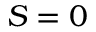<formula> <loc_0><loc_0><loc_500><loc_500>S = 0</formula> 